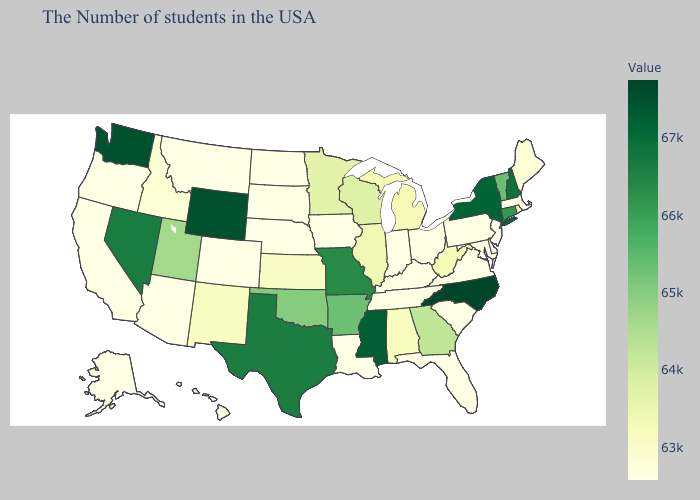Does South Carolina have the highest value in the South?
Short answer required. No. Which states hav the highest value in the MidWest?
Short answer required. Missouri. Does New Hampshire have the lowest value in the Northeast?
Be succinct. No. Among the states that border Arkansas , does Mississippi have the lowest value?
Write a very short answer. No. Does North Carolina have the highest value in the USA?
Write a very short answer. Yes. Does North Carolina have the highest value in the USA?
Concise answer only. Yes. 